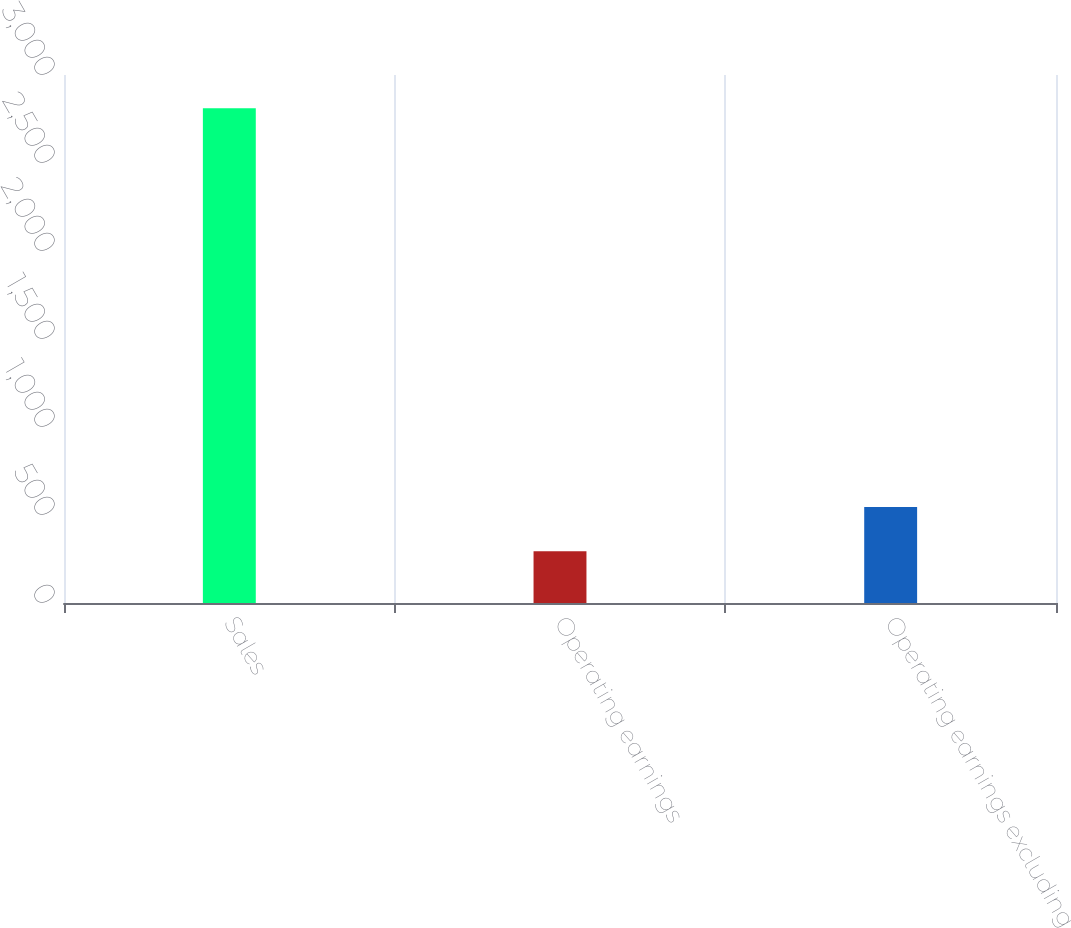<chart> <loc_0><loc_0><loc_500><loc_500><bar_chart><fcel>Sales<fcel>Operating earnings<fcel>Operating earnings excluding<nl><fcel>2811<fcel>294<fcel>545.7<nl></chart> 